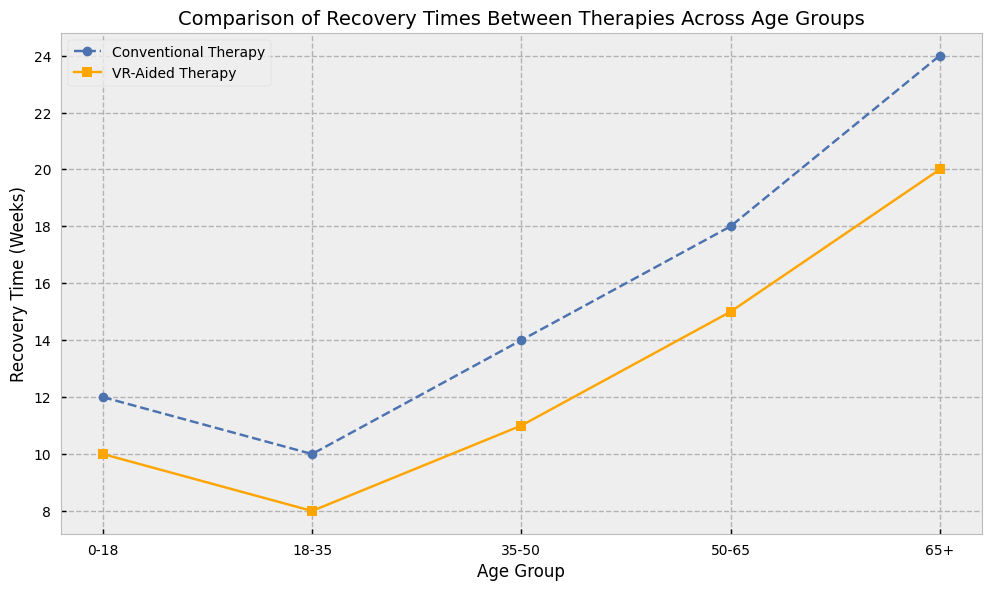What's the difference in recovery time between Conventional Therapy and VR-Aided Therapy for the age group 0-18? Look at the recovery times for the 0-18 age group in the figure. Conventional Therapy takes 12 weeks, while VR-Aided Therapy takes 10 weeks. The difference is 12 - 10 = 2 weeks.
Answer: 2 weeks Which age group shows the largest recovery time difference between Conventional Therapy and VR-Aided Therapy? Observe the differences in recovery times for all age groups. The differences are 2 weeks for 0-18, 2 weeks for 18-35, 3 weeks for 35-50, 3 weeks for 50-65, and 4 weeks for 65+. The largest difference is 4 weeks, seen in the 65+ age group.
Answer: 65+ What is the average recovery time for VR-Aided Therapy across all age groups? Sum the recovery times for VR-Aided Therapy across all age groups and divide by the number of groups. (10 + 8 + 11 + 15 + 20) / 5 = 64 / 5 = 12.8 weeks.
Answer: 12.8 weeks In which age group does VR-Aided Therapy provide the maximum reduction in recovery time compared to Conventional Therapy? Find the difference between recovery times for each age group. The differences are 2 weeks for 0-18, 2 weeks for 18-35, 3 weeks for 35-50, 3 weeks for 50-65, and 4 weeks for 65+. The maximum reduction of 4 weeks is in the 65+ age group.
Answer: 65+ For the age group 50-65, how many weeks less does VR-Aided Therapy take compared to Conventional Therapy? For the 50-65 age group, Conventional Therapy takes 18 weeks, and VR-Aided Therapy takes 15 weeks. The difference is 18 - 15 = 3 weeks.
Answer: 3 weeks What is the total recovery time for both therapies combined for the age group 18-35? Sum the recovery times for both Conventional Therapy and VR-Aided Therapy for the age group 18-35. 10 weeks for Conventional Therapy + 8 weeks for VR-Aided Therapy = 18 weeks.
Answer: 18 weeks Which therapy shows a faster recovery time for the age group 0-18, and by how much? Compare the recovery times for Conventional Therapy and VR-Aided Therapy for the 0-18 age group. VR-Aided Therapy is faster with 10 weeks compared to 12 weeks for Conventional Therapy. The difference is 2 weeks.
Answer: VR-Aided Therapy, 2 weeks Does the gap between the recovery times of the two therapies increase or decrease with age? Observing the figure, the gap increases with age: 2 weeks for 0-18, 2 weeks for 18-35, 3 weeks for 35-50, 3 weeks for 50-65, and 4 weeks for 65+.
Answer: Increase 